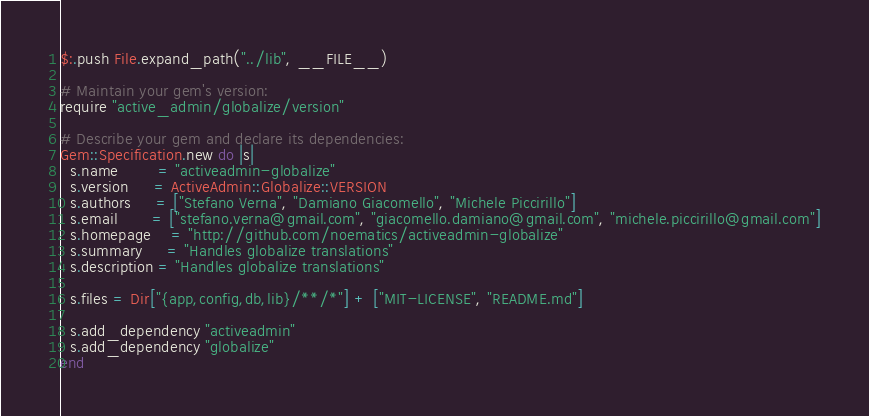Convert code to text. <code><loc_0><loc_0><loc_500><loc_500><_Ruby_>$:.push File.expand_path("../lib", __FILE__)

# Maintain your gem's version:
require "active_admin/globalize/version"

# Describe your gem and declare its dependencies:
Gem::Specification.new do |s|
  s.name        = "activeadmin-globalize"
  s.version     = ActiveAdmin::Globalize::VERSION
  s.authors     = ["Stefano Verna", "Damiano Giacomello", "Michele Piccirillo"]
  s.email       = ["stefano.verna@gmail.com", "giacomello.damiano@gmail.com", "michele.piccirillo@gmail.com"]
  s.homepage    = "http://github.com/noematics/activeadmin-globalize"
  s.summary     = "Handles globalize translations"
  s.description = "Handles globalize translations"

  s.files = Dir["{app,config,db,lib}/**/*"] + ["MIT-LICENSE", "README.md"]

  s.add_dependency "activeadmin"
  s.add_dependency "globalize"
end

</code> 